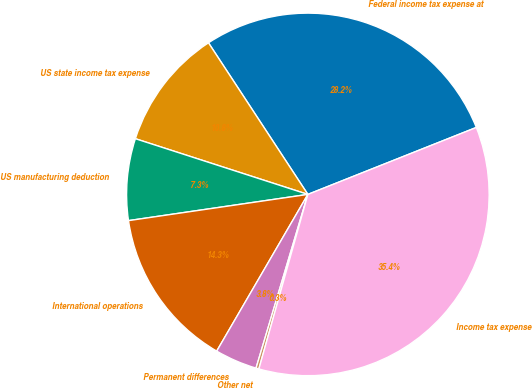<chart> <loc_0><loc_0><loc_500><loc_500><pie_chart><fcel>Federal income tax expense at<fcel>US state income tax expense<fcel>US manufacturing deduction<fcel>International operations<fcel>Permanent differences<fcel>Other net<fcel>Income tax expense<nl><fcel>28.21%<fcel>10.79%<fcel>7.28%<fcel>14.3%<fcel>3.77%<fcel>0.26%<fcel>35.37%<nl></chart> 